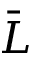<formula> <loc_0><loc_0><loc_500><loc_500>\bar { L }</formula> 